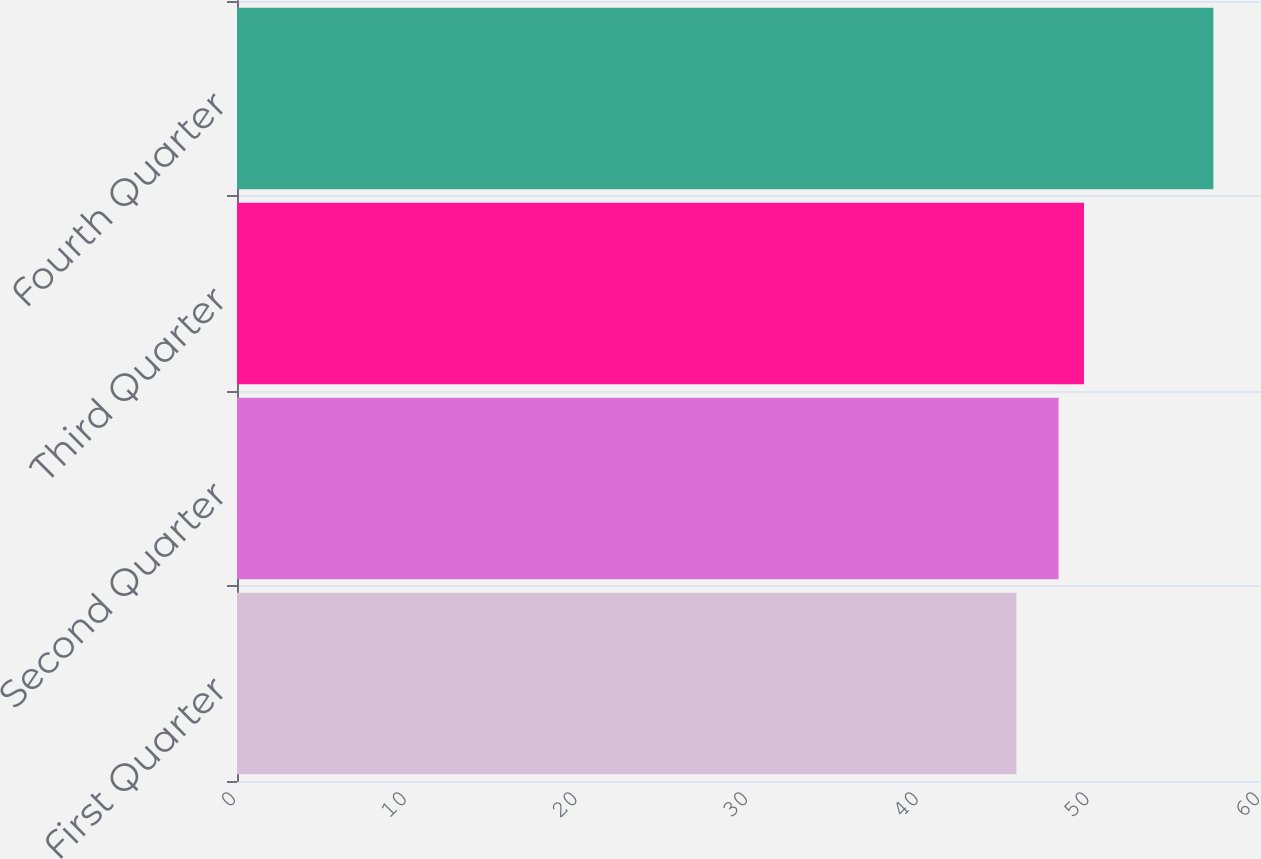Convert chart. <chart><loc_0><loc_0><loc_500><loc_500><bar_chart><fcel>First Quarter<fcel>Second Quarter<fcel>Third Quarter<fcel>Fourth Quarter<nl><fcel>45.67<fcel>48.14<fcel>49.63<fcel>57.21<nl></chart> 